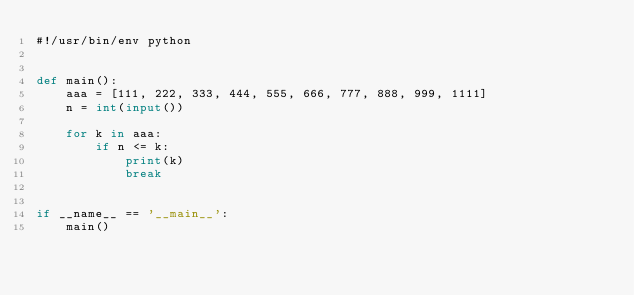Convert code to text. <code><loc_0><loc_0><loc_500><loc_500><_Python_>#!/usr/bin/env python


def main():
    aaa = [111, 222, 333, 444, 555, 666, 777, 888, 999, 1111]
    n = int(input())

    for k in aaa:
        if n <= k:
            print(k)
            break


if __name__ == '__main__':
    main()
</code> 